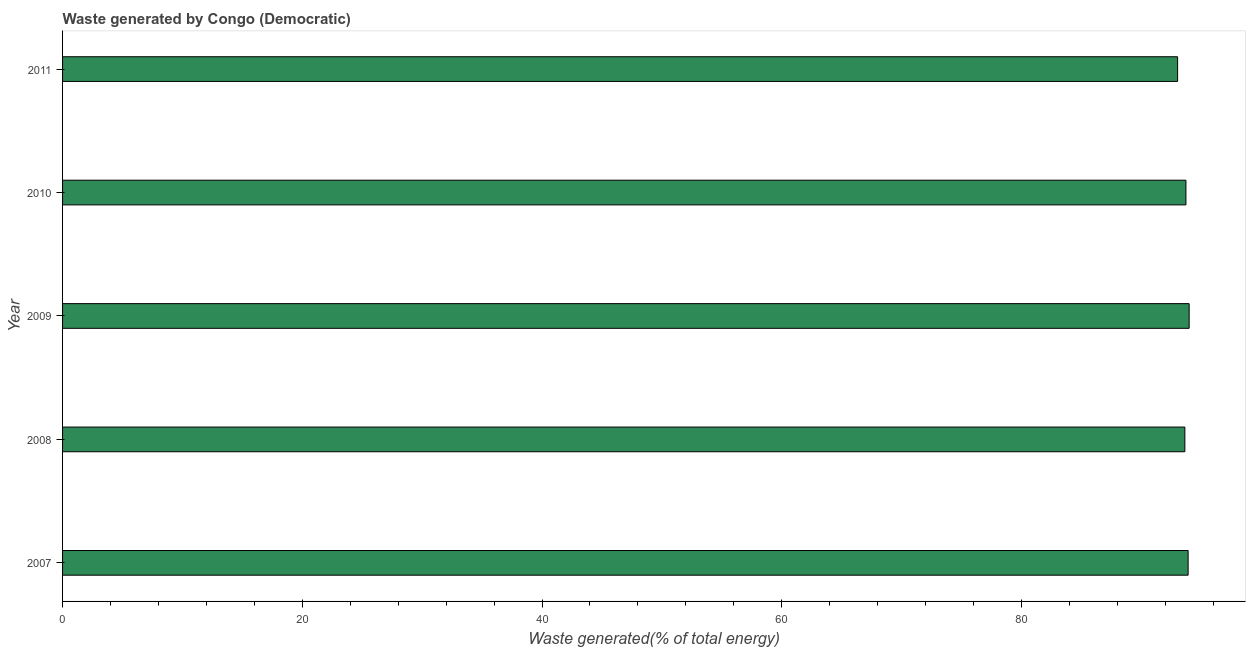Does the graph contain any zero values?
Offer a very short reply. No. What is the title of the graph?
Make the answer very short. Waste generated by Congo (Democratic). What is the label or title of the X-axis?
Offer a very short reply. Waste generated(% of total energy). What is the amount of waste generated in 2011?
Make the answer very short. 93.02. Across all years, what is the maximum amount of waste generated?
Offer a very short reply. 93.99. Across all years, what is the minimum amount of waste generated?
Ensure brevity in your answer.  93.02. What is the sum of the amount of waste generated?
Keep it short and to the point. 468.26. What is the difference between the amount of waste generated in 2007 and 2008?
Offer a very short reply. 0.27. What is the average amount of waste generated per year?
Ensure brevity in your answer.  93.65. What is the median amount of waste generated?
Make the answer very short. 93.72. In how many years, is the amount of waste generated greater than 56 %?
Provide a short and direct response. 5. Do a majority of the years between 2011 and 2010 (inclusive) have amount of waste generated greater than 32 %?
Offer a very short reply. No. Is the amount of waste generated in 2010 less than that in 2011?
Your answer should be compact. No. Is the difference between the amount of waste generated in 2007 and 2008 greater than the difference between any two years?
Your answer should be very brief. No. What is the difference between the highest and the second highest amount of waste generated?
Make the answer very short. 0.09. How many bars are there?
Your answer should be compact. 5. Are all the bars in the graph horizontal?
Offer a very short reply. Yes. How many years are there in the graph?
Give a very brief answer. 5. What is the difference between two consecutive major ticks on the X-axis?
Give a very brief answer. 20. Are the values on the major ticks of X-axis written in scientific E-notation?
Ensure brevity in your answer.  No. What is the Waste generated(% of total energy) of 2007?
Your answer should be very brief. 93.9. What is the Waste generated(% of total energy) of 2008?
Keep it short and to the point. 93.63. What is the Waste generated(% of total energy) in 2009?
Ensure brevity in your answer.  93.99. What is the Waste generated(% of total energy) of 2010?
Your answer should be very brief. 93.72. What is the Waste generated(% of total energy) in 2011?
Give a very brief answer. 93.02. What is the difference between the Waste generated(% of total energy) in 2007 and 2008?
Provide a succinct answer. 0.27. What is the difference between the Waste generated(% of total energy) in 2007 and 2009?
Offer a very short reply. -0.09. What is the difference between the Waste generated(% of total energy) in 2007 and 2010?
Your answer should be compact. 0.18. What is the difference between the Waste generated(% of total energy) in 2007 and 2011?
Ensure brevity in your answer.  0.88. What is the difference between the Waste generated(% of total energy) in 2008 and 2009?
Offer a very short reply. -0.36. What is the difference between the Waste generated(% of total energy) in 2008 and 2010?
Your response must be concise. -0.09. What is the difference between the Waste generated(% of total energy) in 2008 and 2011?
Your response must be concise. 0.6. What is the difference between the Waste generated(% of total energy) in 2009 and 2010?
Provide a succinct answer. 0.27. What is the difference between the Waste generated(% of total energy) in 2009 and 2011?
Provide a short and direct response. 0.96. What is the difference between the Waste generated(% of total energy) in 2010 and 2011?
Keep it short and to the point. 0.69. What is the ratio of the Waste generated(% of total energy) in 2007 to that in 2011?
Offer a very short reply. 1.01. What is the ratio of the Waste generated(% of total energy) in 2008 to that in 2009?
Give a very brief answer. 1. What is the ratio of the Waste generated(% of total energy) in 2008 to that in 2010?
Your answer should be compact. 1. What is the ratio of the Waste generated(% of total energy) in 2009 to that in 2011?
Make the answer very short. 1.01. 